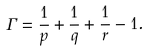Convert formula to latex. <formula><loc_0><loc_0><loc_500><loc_500>\Gamma = \frac { 1 } { p } + \frac { 1 } { q } + \frac { 1 } { r } - 1 .</formula> 